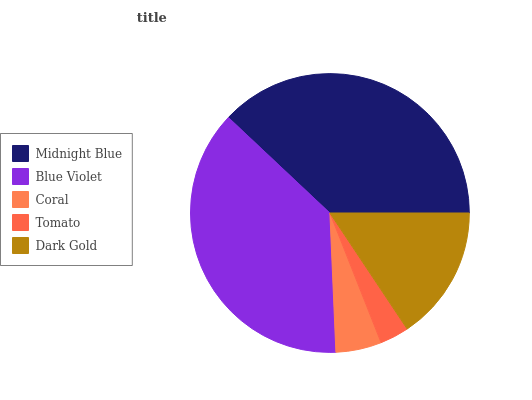Is Tomato the minimum?
Answer yes or no. Yes. Is Midnight Blue the maximum?
Answer yes or no. Yes. Is Blue Violet the minimum?
Answer yes or no. No. Is Blue Violet the maximum?
Answer yes or no. No. Is Midnight Blue greater than Blue Violet?
Answer yes or no. Yes. Is Blue Violet less than Midnight Blue?
Answer yes or no. Yes. Is Blue Violet greater than Midnight Blue?
Answer yes or no. No. Is Midnight Blue less than Blue Violet?
Answer yes or no. No. Is Dark Gold the high median?
Answer yes or no. Yes. Is Dark Gold the low median?
Answer yes or no. Yes. Is Coral the high median?
Answer yes or no. No. Is Blue Violet the low median?
Answer yes or no. No. 